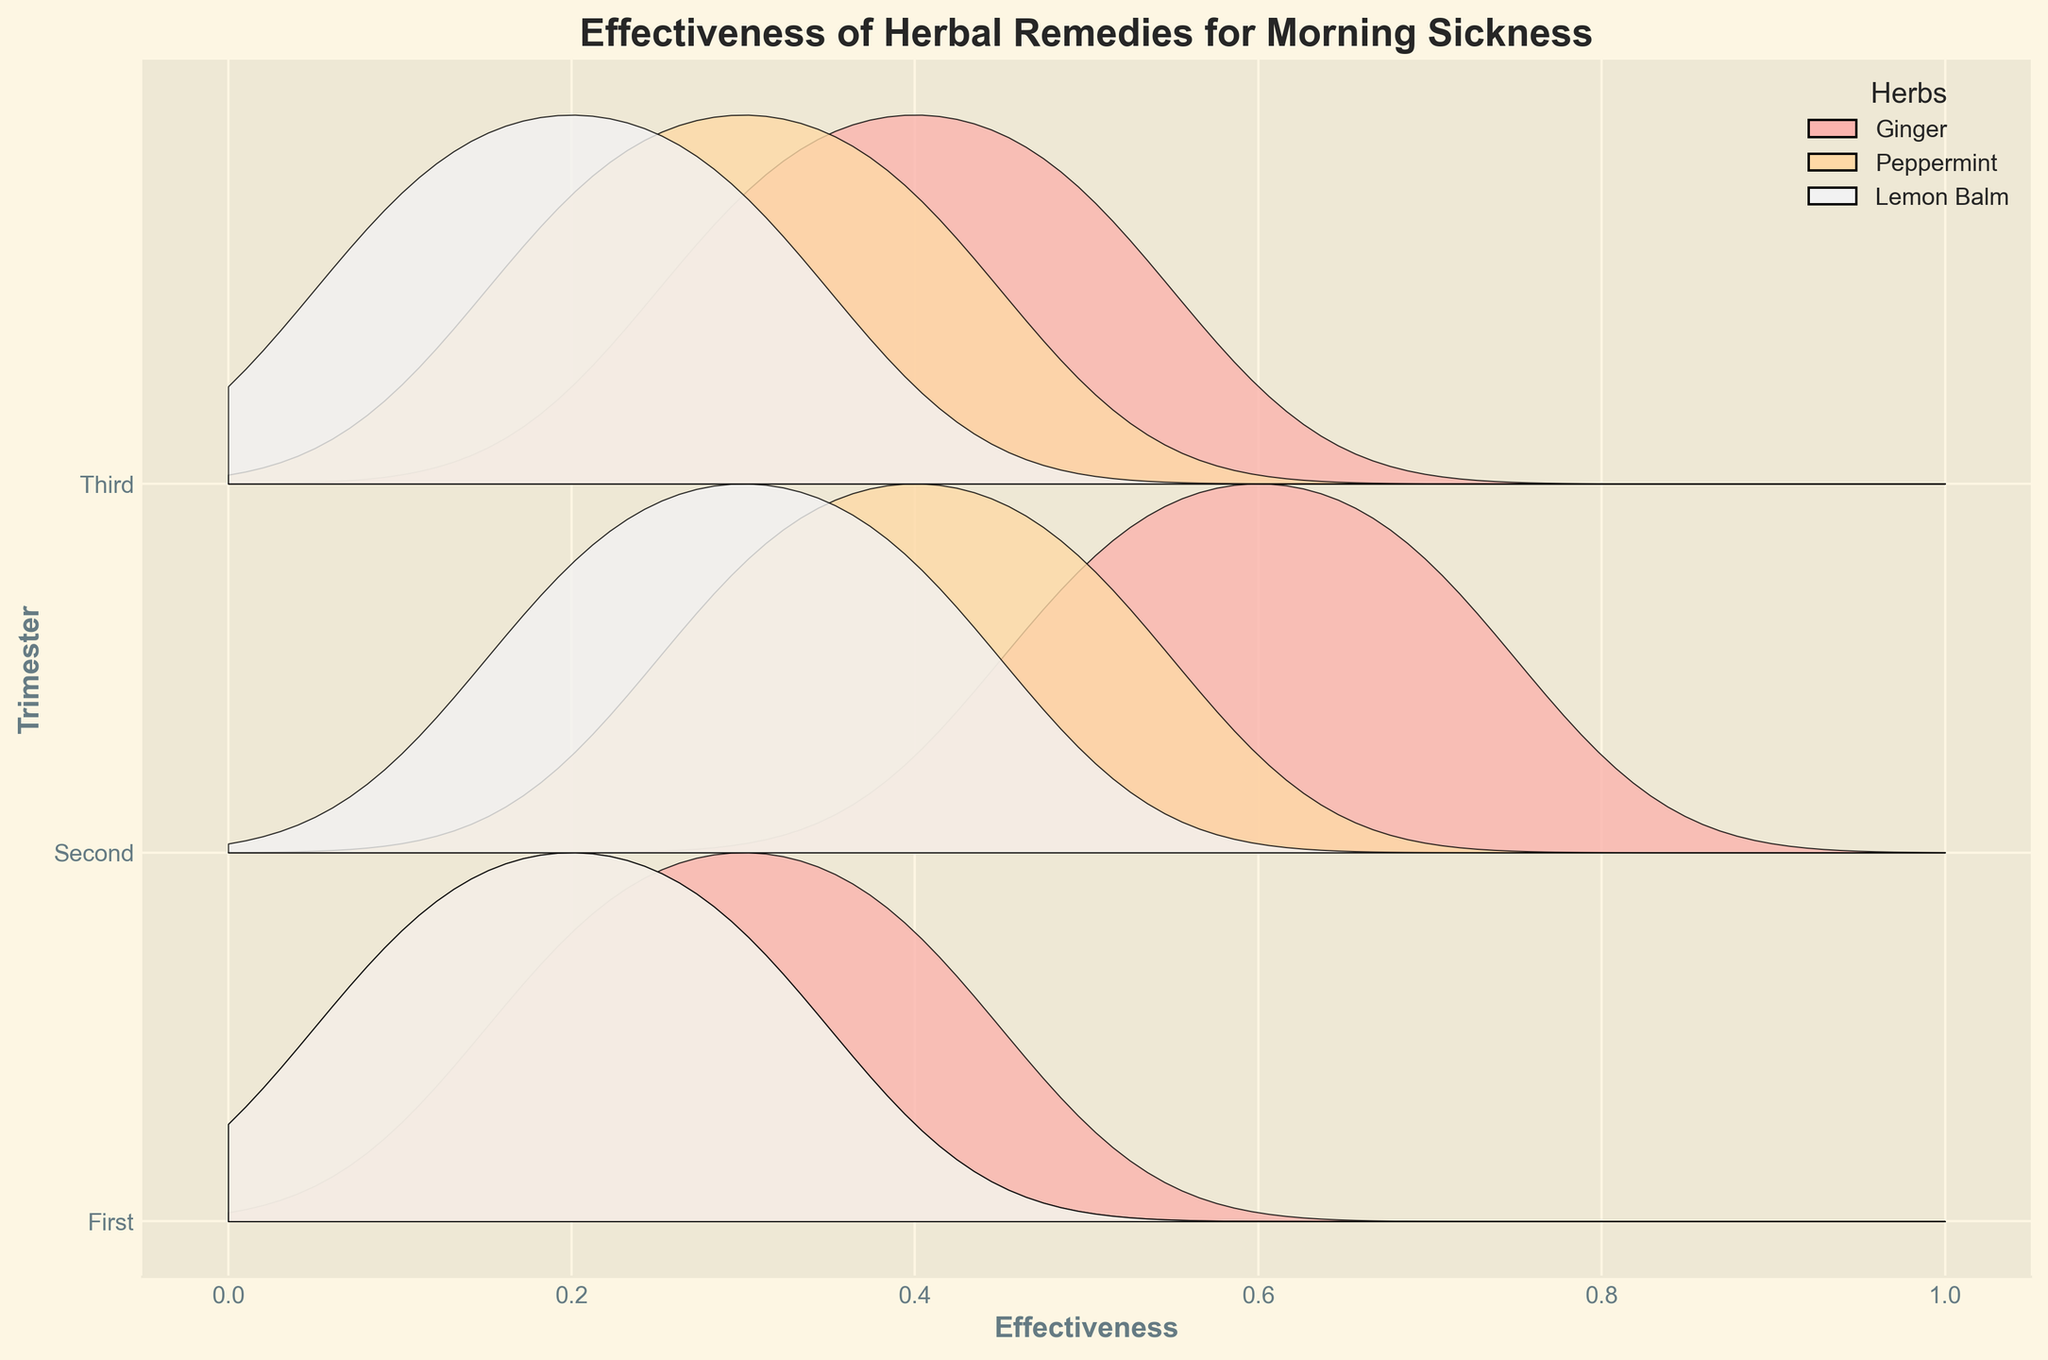How many types of herbs are shown in the plot? The legend at the upper right of the plot lists the types of herbs.
Answer: 3 Which trimester has the highest effectiveness rating for Ginger? To find this, compare the effectiveness ratings for Ginger across the three trimesters. The second trimester has the highest densities for Ginger effectiveness around 0.5 to 0.7, higher than in the first and third.
Answer: Second How does the effectiveness of Lemon Balm in the first trimester compare to the third trimester? By looking at the ridges, the Lemon Balm effectiveness in the first trimester mostly clusters around 0.1 to 0.3, while in the third trimester it also clusters similarly around 0.1 to 0.3. They appear quite similar in distribution.
Answer: Similar What is the overall trend of Peppermint's effectiveness across the trimesters? Compare the density curves for Peppermint across each trimester. The effectiveness ratings increase over time: from 0.1 to 0.3 in the first trimester, 0.3 to 0.5 in the second, and 0.2 to 0.4 in the third.
Answer: Increasing Which herb shows the widest range of effectiveness ratings in the second trimester? By examining the width of the ridgelines, Ginger has the widest range (0.5 to 0.7) for the second trimester compared to Peppermint (0.3 to 0.5) and Lemon Balm (0.2 to 0.4).
Answer: Ginger What is the title of the plot? The title is displayed at the top of the figure.
Answer: Effectiveness of Herbal Remedies for Morning Sickness Between Ginger and Lemon Balm, which herb shows a more consistent effectiveness rating in the third trimester? Look at the shape of the density curves. Ginger has a wider distribution (0.3 to 0.5) compared to Lemon Balm, which is more narrow and consistent around 0.1 to 0.3.
Answer: Lemon Balm 